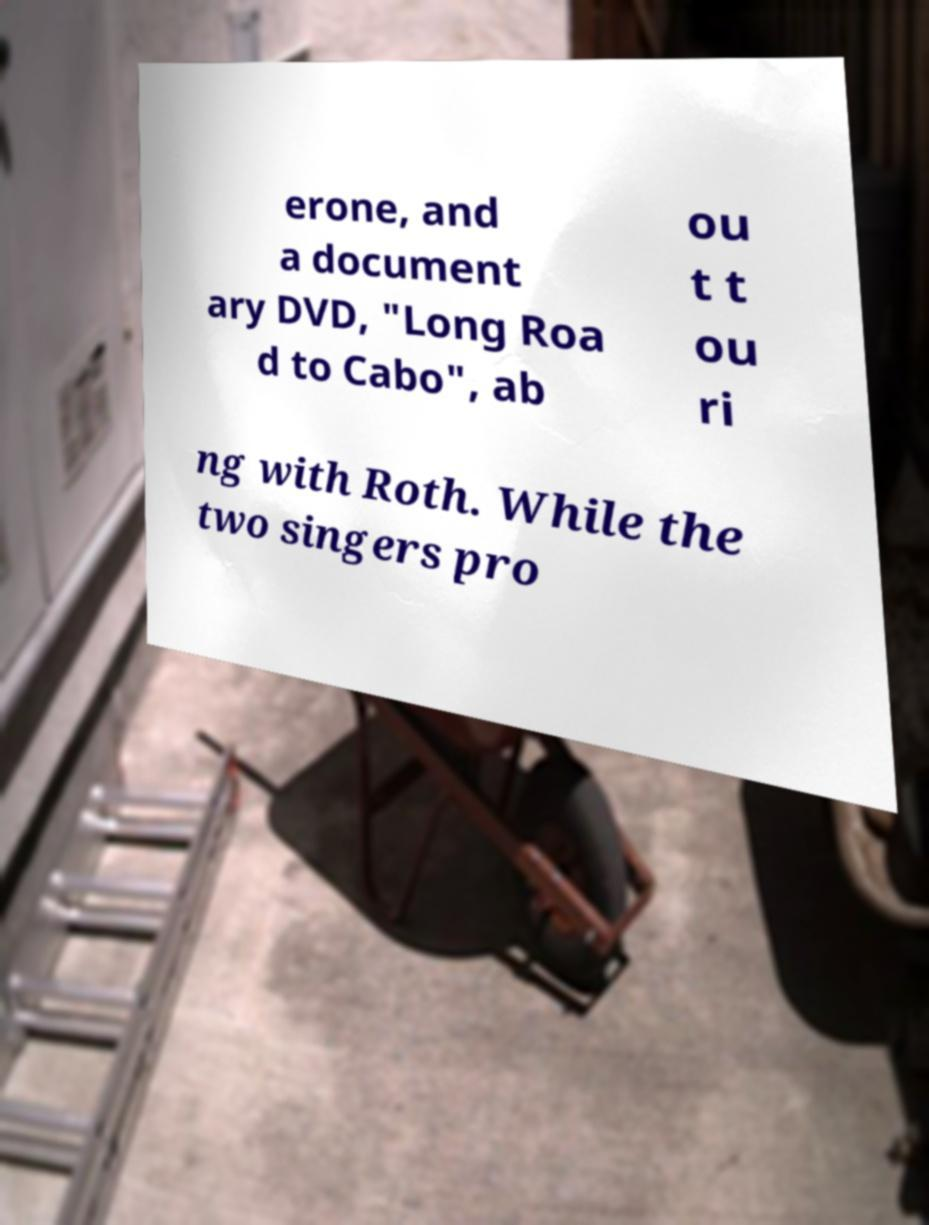Please read and relay the text visible in this image. What does it say? erone, and a document ary DVD, "Long Roa d to Cabo", ab ou t t ou ri ng with Roth. While the two singers pro 